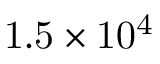Convert formula to latex. <formula><loc_0><loc_0><loc_500><loc_500>1 . 5 \times 1 0 ^ { 4 }</formula> 